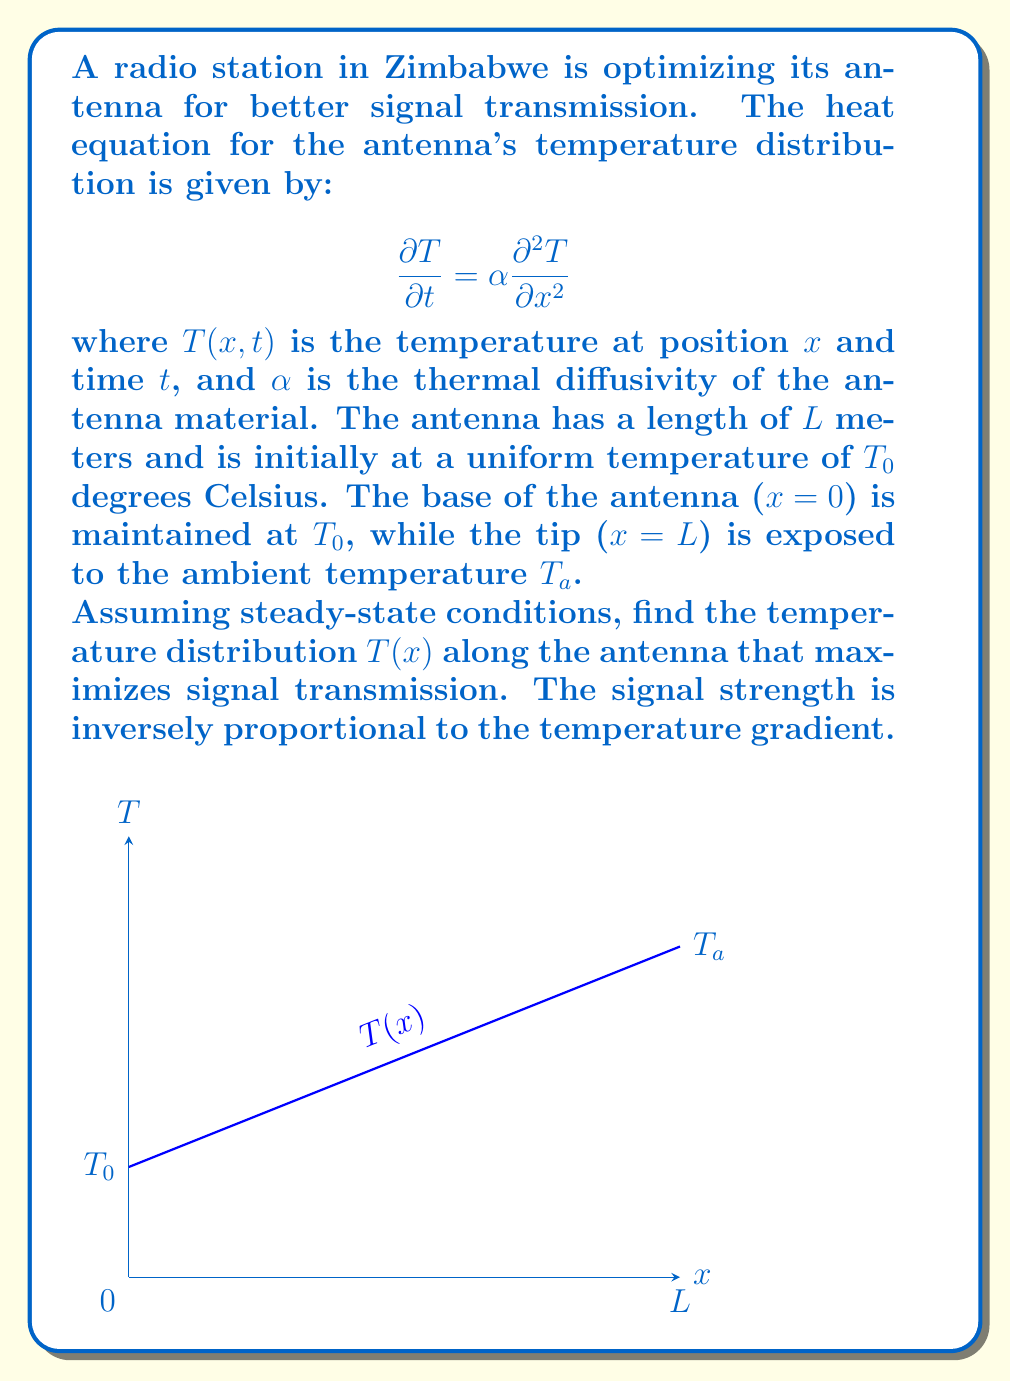Can you solve this math problem? Let's solve this problem step by step:

1) For steady-state conditions, $\frac{\partial T}{\partial t} = 0$. The heat equation reduces to:

   $$0 = \alpha \frac{d^2 T}{dx^2}$$

2) This simplifies to:

   $$\frac{d^2 T}{dx^2} = 0$$

3) Integrating twice:

   $$\frac{dT}{dx} = C_1$$
   $$T(x) = C_1x + C_2$$

4) Apply the boundary conditions:
   At $x = 0$, $T(0) = T_0$, so $C_2 = T_0$
   At $x = L$, $T(L) = T_a$, so $T_a = C_1L + T_0$

5) Solving for $C_1$:

   $$C_1 = \frac{T_a - T_0}{L}$$

6) Therefore, the temperature distribution is:

   $$T(x) = \frac{T_a - T_0}{L}x + T_0$$

7) The temperature gradient is:

   $$\frac{dT}{dx} = \frac{T_a - T_0}{L}$$

8) To maximize signal transmission, we need to minimize the temperature gradient. This occurs when $T_a$ is as close to $T_0$ as possible.

9) Ideally, $T_a = T_0$, which would result in a uniform temperature distribution:

   $$T(x) = T_0$$

   This would give a temperature gradient of zero, maximizing signal transmission.
Answer: $T(x) = T_0$ (when $T_a = T_0$) 